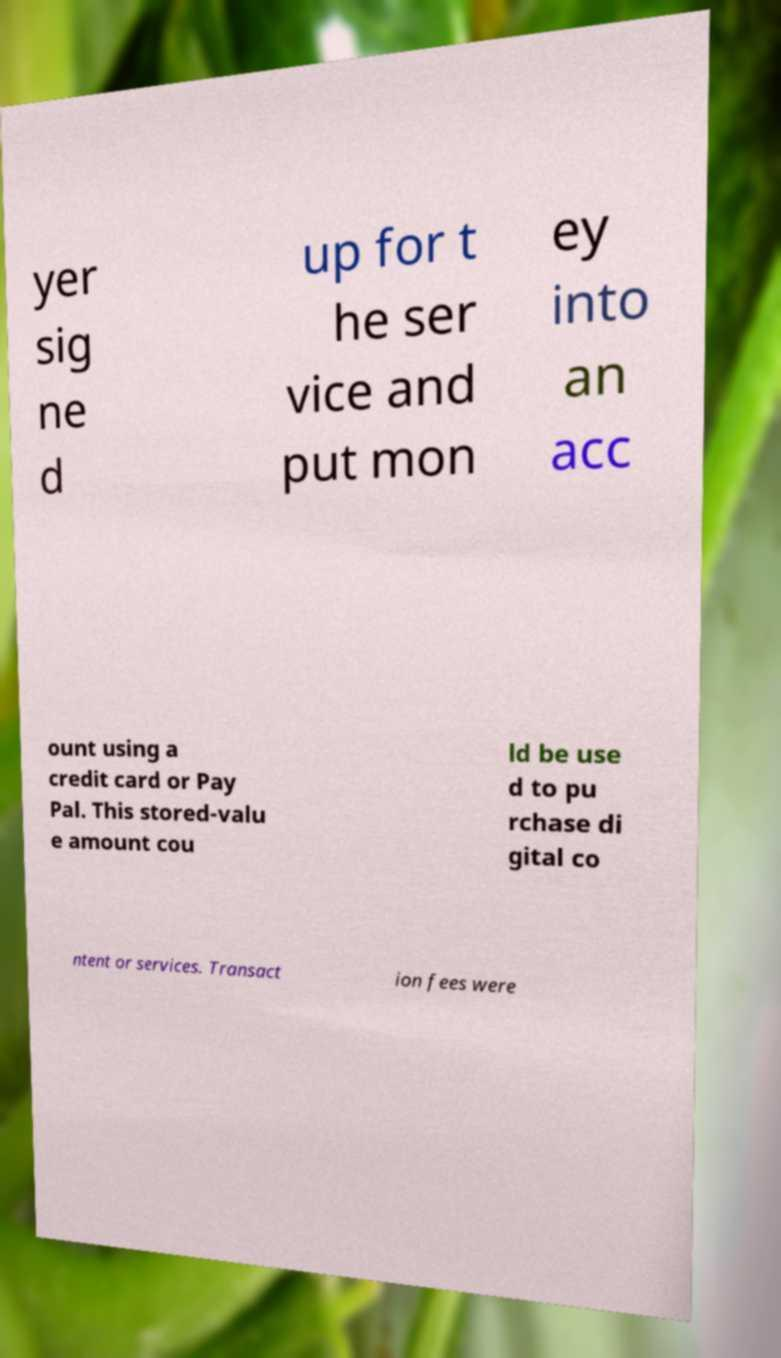Please read and relay the text visible in this image. What does it say? yer sig ne d up for t he ser vice and put mon ey into an acc ount using a credit card or Pay Pal. This stored-valu e amount cou ld be use d to pu rchase di gital co ntent or services. Transact ion fees were 